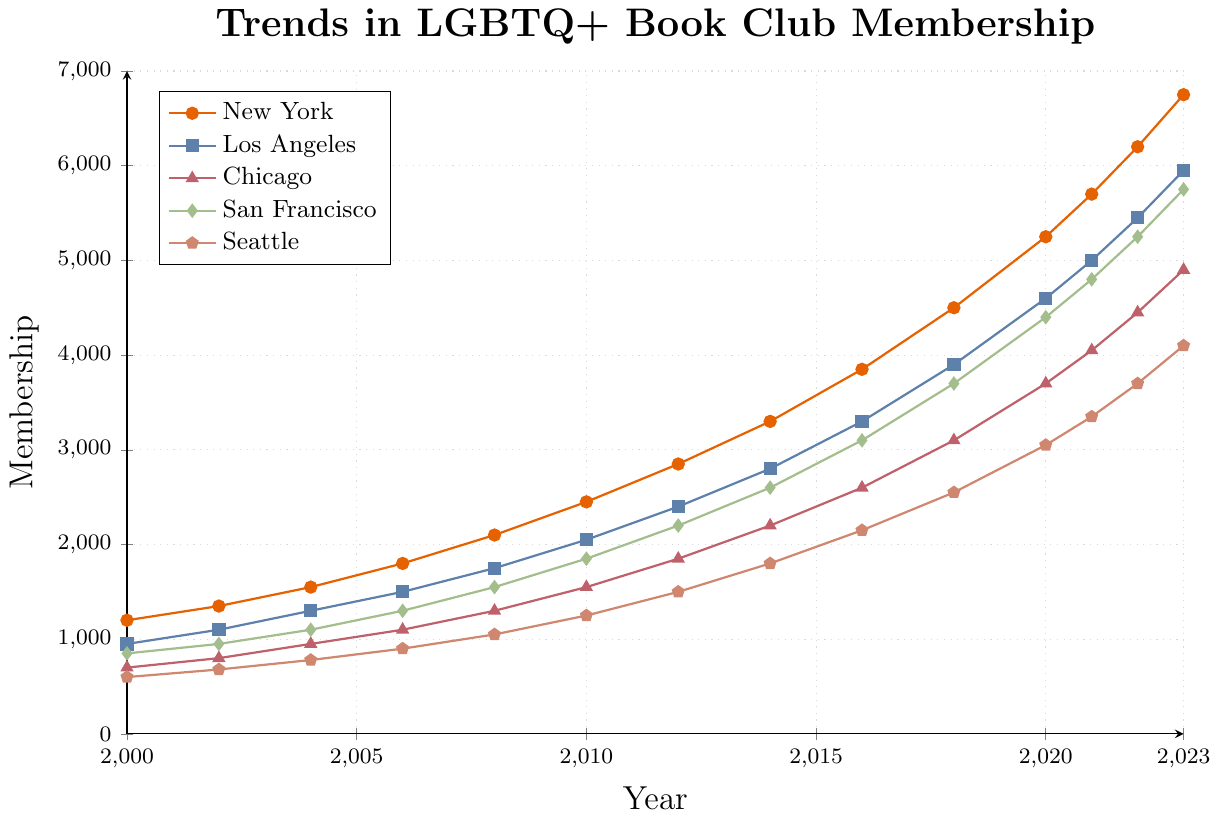Which city had the highest LGBTQ+ book club membership in 2023? By examining the year 2023 on the x-axis and comparing the heights of the lines representing each city's membership, the highest line corresponds to New York.
Answer: New York Between 2006 and 2008, which city's membership grew the most? The membership values for 2006 and 2008 are New York (1800 to 2100), Los Angeles (1500 to 1750), Chicago (1100 to 1300), San Francisco (1300 to 1550), and Seattle (900 to 1050). The growth is calculated as follows: New York (300), Los Angeles (250), Chicago (200), San Francisco (250), Seattle (150). New York had the highest increase of 300 members.
Answer: New York What's the difference in LGBTQ+ book club membership between New York and Seattle in 2023? In 2023, the membership for New York is 6750 and for Seattle is 4100. The difference is calculated as 6750 - 4100 = 2650.
Answer: 2650 Which city had the largest membership increase from 2000 to 2023? The membership values in 2000 and 2023 for each city are: New York (1200 to 6750), Los Angeles (950 to 5950), Chicago (700 to 4900), San Francisco (850 to 5750), and Seattle (600 to 4100). New York had the largest increase: 6750 - 1200 = 5550.
Answer: New York Which two cities had the closest membership values in 2018? In 2018, the membership values are: New York (4500), Los Angeles (3900), Chicago (3100), San Francisco (3700), Seattle (2550). The closest values are between Los Angeles (3900) and San Francisco (3700), with a difference of 3900 - 3700 = 200.
Answer: Los Angeles and San Francisco What is the average membership for Chicago from 2000 to 2023? The membership values for Chicago from 2000 to 2023 are: 700, 800, 950, 1100, 1300, 1550, 1850, 2200, 2600, 3100, 3700, 4050, 4450, 4900. Sum these values to get 34050. There are 14 years, so the average is 34050 / 14 = 2432.14.
Answer: 2432.14 In which year did Seattle first surpass 2000 members? By tracing the Seattle line, it surpasses the 2000 mark on the y-axis after 2014 (1800 members) in 2016 (2150 members).
Answer: 2016 Which city showed the most steady growth from 2000 to 2023? By observing the slopes of the lines, Los Angeles has a consistent and steady increase in membership over the years without abrupt changes.
Answer: Los Angeles How does the growth rate of San Francisco compare to Chicago from 2000 to 2023? The membership values for San Francisco increase from 850 in 2000 to 5750 in 2023, an increase of 4900 members. For Chicago, it increases from 700 to 4900, an increase of 4200 members. San Francisco has grown by 4900 / 23 ≈ 213.04 members per year on average, and Chicago by 4200 / 23 ≈ 182.61 members per year.
Answer: San Francisco has a higher growth rate Between 2020 and 2021, which city's membership increased the least? The membership values from 2020 to 2021 are: New York (5250 to 5700), Los Angeles (4600 to 5000), Chicago (3700 to 4050), San Francisco (4400 to 4800), Seattle (3050 to 3350). The differences are: New York (450), Los Angeles (400), Chicago (350), San Francisco (400), Seattle (300). Seattle shows the least increase of 300.
Answer: Seattle 